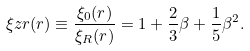Convert formula to latex. <formula><loc_0><loc_0><loc_500><loc_500>\xi z r ( r ) \equiv \frac { \xi _ { 0 } ( r ) } { \xi _ { R } ( r ) } = 1 + \frac { 2 } { 3 } \beta + \frac { 1 } { 5 } \beta ^ { 2 } .</formula> 